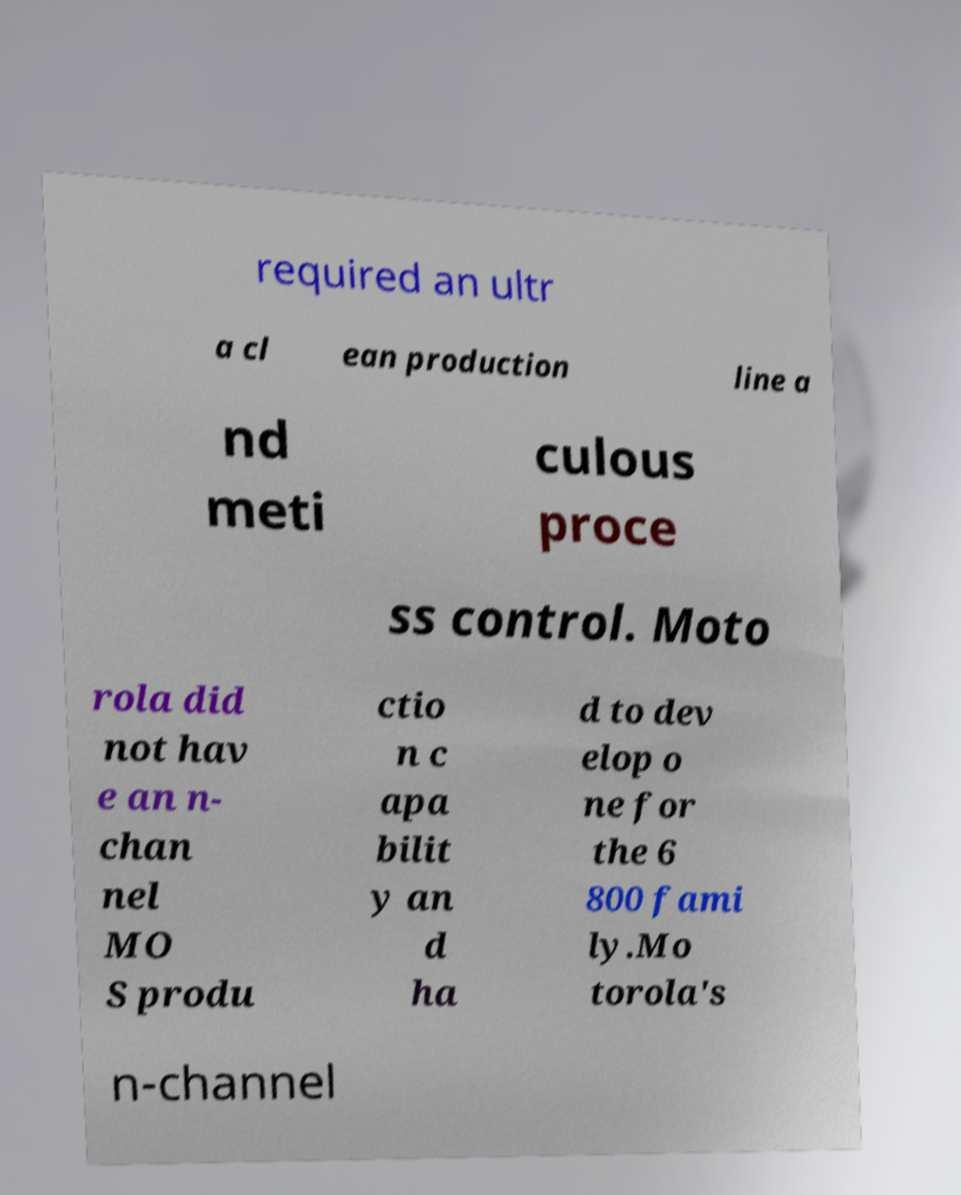I need the written content from this picture converted into text. Can you do that? required an ultr a cl ean production line a nd meti culous proce ss control. Moto rola did not hav e an n- chan nel MO S produ ctio n c apa bilit y an d ha d to dev elop o ne for the 6 800 fami ly.Mo torola's n-channel 